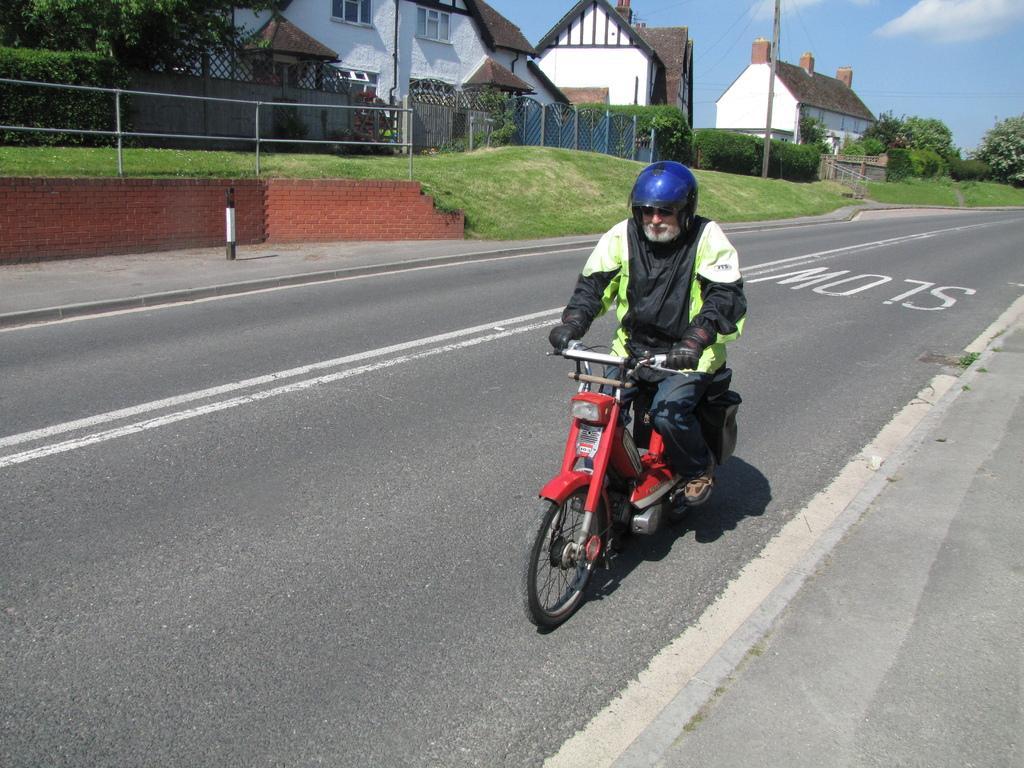Please provide a concise description of this image. A person is riding a motorbike and wore a helmet. Background there are houses with windows, plants, trees and grass.  